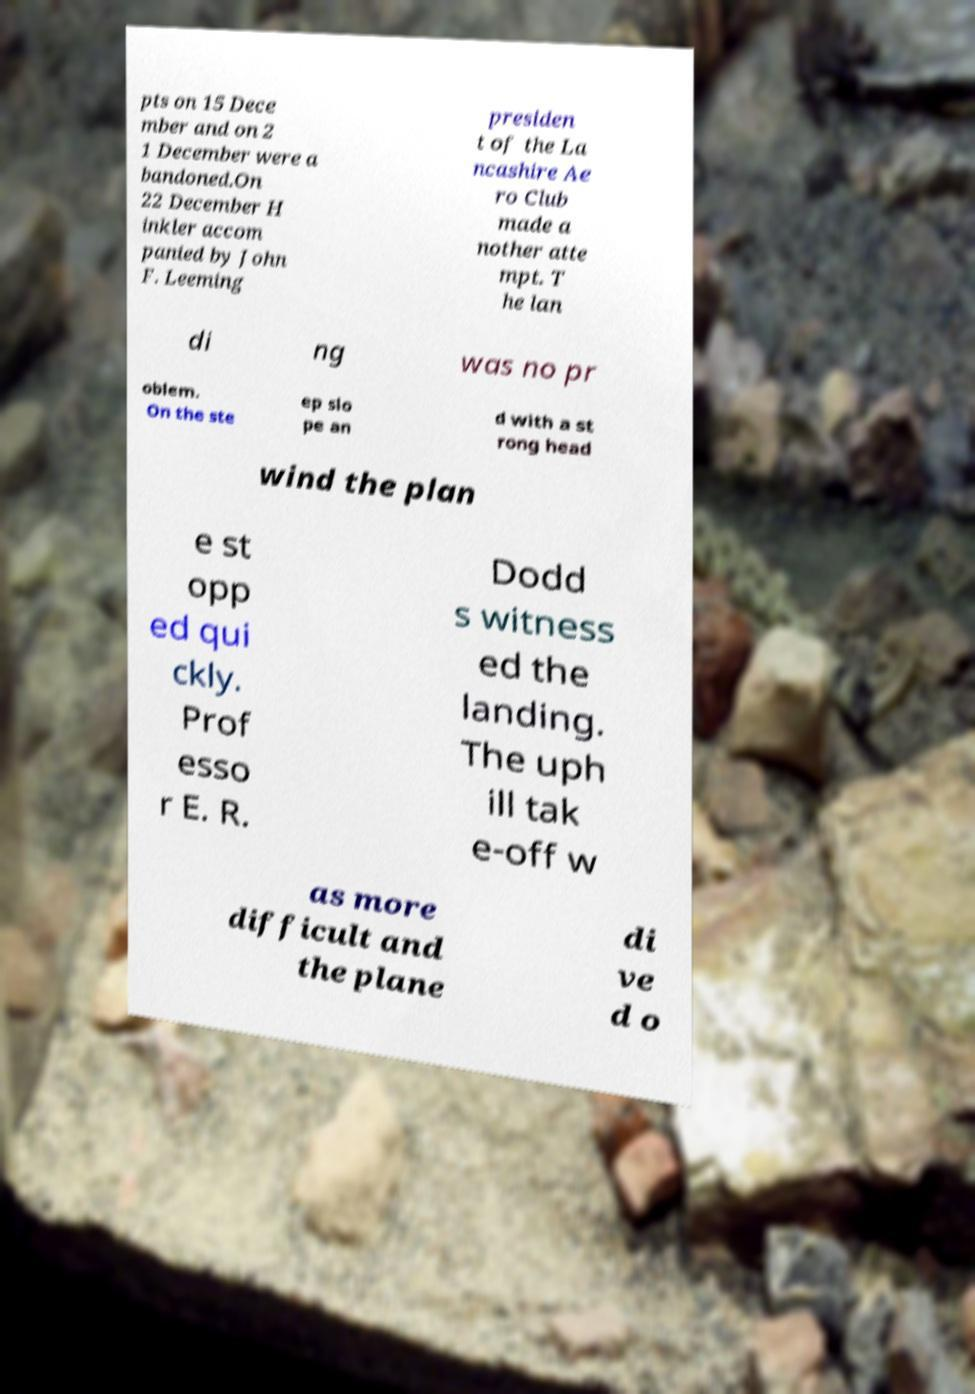Please read and relay the text visible in this image. What does it say? pts on 15 Dece mber and on 2 1 December were a bandoned.On 22 December H inkler accom panied by John F. Leeming presiden t of the La ncashire Ae ro Club made a nother atte mpt. T he lan di ng was no pr oblem. On the ste ep slo pe an d with a st rong head wind the plan e st opp ed qui ckly. Prof esso r E. R. Dodd s witness ed the landing. The uph ill tak e-off w as more difficult and the plane di ve d o 